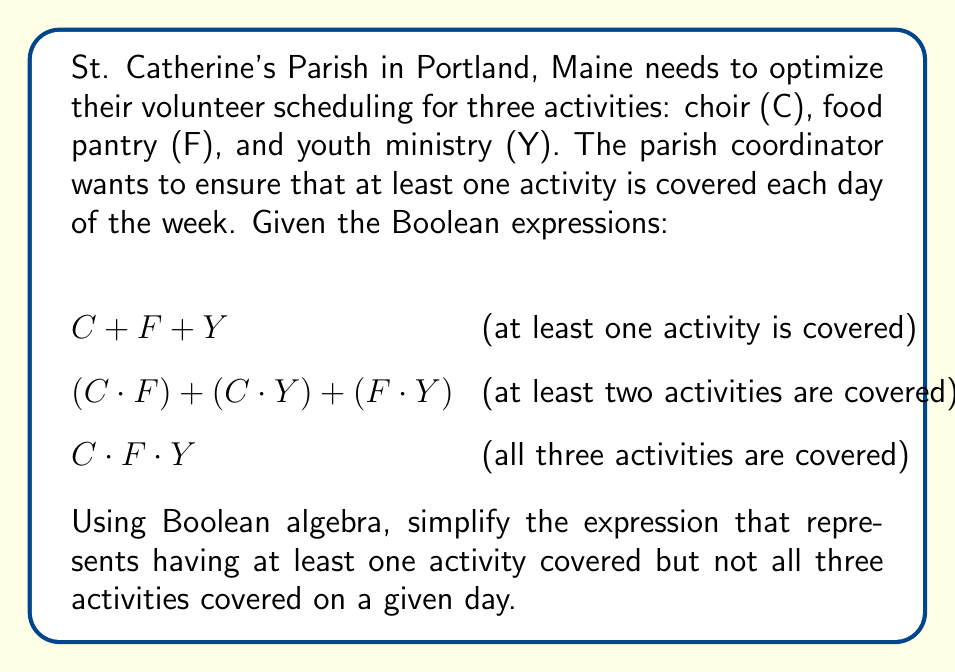Give your solution to this math problem. Let's approach this step-by-step:

1) The expression we need is:
   (at least one activity) AND NOT (all three activities)

2) In Boolean algebra, this can be written as:
   $$(C + F + Y) \cdot \overline{(C \cdot F \cdot Y)}$$

3) Let's focus on simplifying $\overline{(C \cdot F \cdot Y)}$ first:
   Using De Morgan's Law: $\overline{(A \cdot B)} = \overline{A} + \overline{B}$
   $$\overline{(C \cdot F \cdot Y)} = \overline{C} + \overline{F} + \overline{Y}$$

4) Now our expression is:
   $$(C + F + Y) \cdot (\overline{C} + \overline{F} + \overline{Y})$$

5) Expanding this using the distributive law:
   $$(C \cdot \overline{C}) + (C \cdot \overline{F}) + (C \cdot \overline{Y}) + 
     (F \cdot \overline{C}) + (F \cdot \overline{F}) + (F \cdot \overline{Y}) + 
     (Y \cdot \overline{C}) + (Y \cdot \overline{F}) + (Y \cdot \overline{Y})$$

6) Simplify:
   - $A \cdot \overline{A} = 0$ (contradiction)
   - $A \cdot \overline{B} = A - (A \cdot B)$ (subtraction in Boolean algebra)

7) After simplification:
   $$(C - (C \cdot F)) + (C - (C \cdot Y)) + 
     (F - (F \cdot C)) + (F - (F \cdot Y)) + 
     (Y - (Y \cdot C)) + (Y - (Y \cdot F))$$

8) Combining like terms:
   $$C + F + Y - (C \cdot F) - (C \cdot Y) - (F \cdot Y)$$

9) This can be written as:
   $$(C + F + Y) - ((C \cdot F) + (C \cdot Y) + (F \cdot Y))$$

This final expression represents having at least one activity covered but not all three activities covered on a given day.
Answer: $$(C + F + Y) - ((C \cdot F) + (C \cdot Y) + (F \cdot Y))$$ 